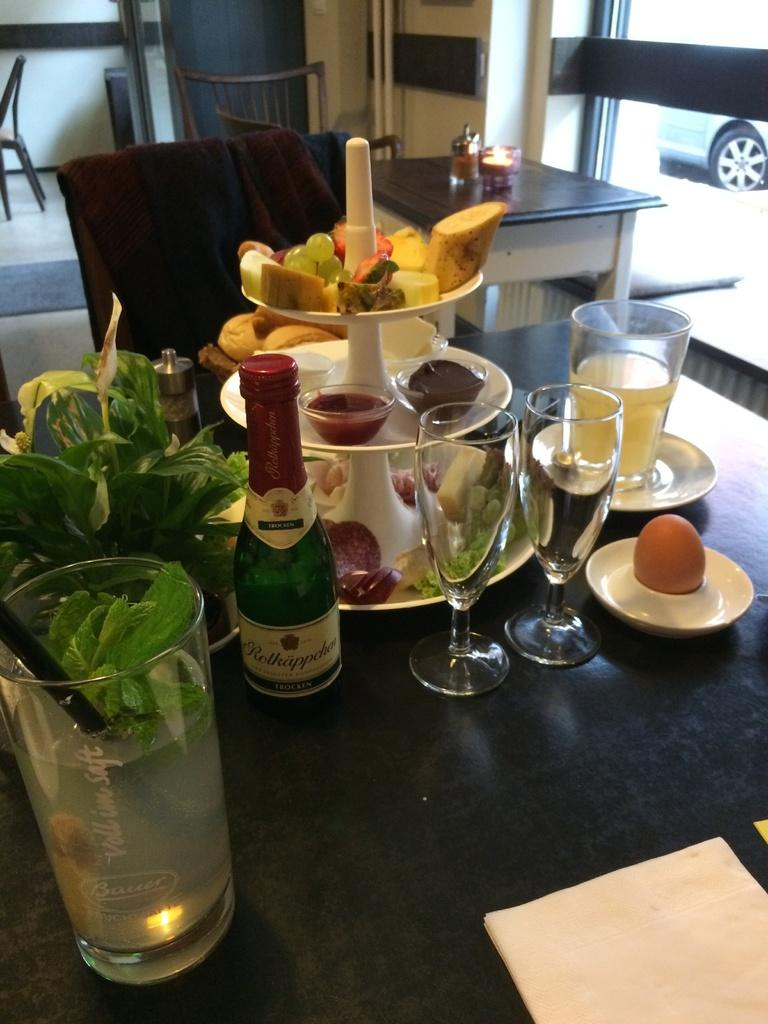What objects are on the table in the image? There are glasses, a plant, and food items on the table in the image. What type of seating is visible in the image? There are chairs in the image. Can you describe the background of the image? There is a car visible in the background. What type of brush is being used to apply friction to the car in the image? There is no brush or friction being applied to the car in the image; it is simply visible in the background. 